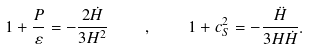Convert formula to latex. <formula><loc_0><loc_0><loc_500><loc_500>1 + \frac { P } { \varepsilon } = - \frac { 2 \dot { H } } { 3 H ^ { 2 } } \quad , \quad 1 + c _ { S } ^ { 2 } = - \frac { \ddot { H } } { 3 H \dot { H } } .</formula> 